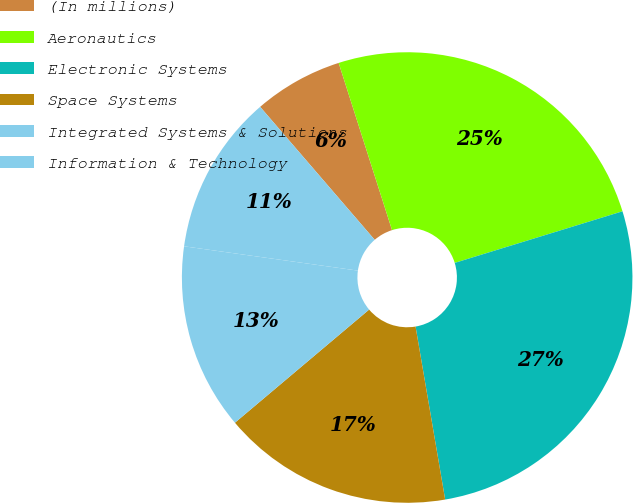Convert chart to OTSL. <chart><loc_0><loc_0><loc_500><loc_500><pie_chart><fcel>(In millions)<fcel>Aeronautics<fcel>Electronic Systems<fcel>Space Systems<fcel>Integrated Systems & Solutions<fcel>Information & Technology<nl><fcel>6.4%<fcel>25.17%<fcel>27.05%<fcel>16.55%<fcel>13.36%<fcel>11.47%<nl></chart> 